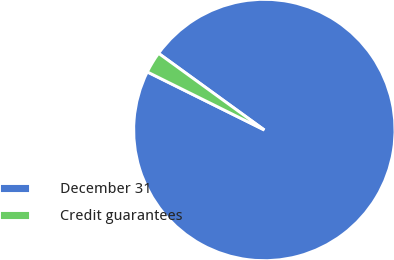<chart> <loc_0><loc_0><loc_500><loc_500><pie_chart><fcel>December 31<fcel>Credit guarantees<nl><fcel>97.35%<fcel>2.65%<nl></chart> 